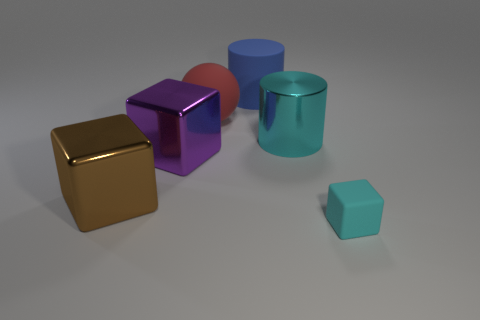Add 1 cyan matte cubes. How many objects exist? 7 Subtract all spheres. How many objects are left? 5 Add 6 large red shiny objects. How many large red shiny objects exist? 6 Subtract 0 yellow blocks. How many objects are left? 6 Subtract all big purple balls. Subtract all rubber blocks. How many objects are left? 5 Add 3 large metal blocks. How many large metal blocks are left? 5 